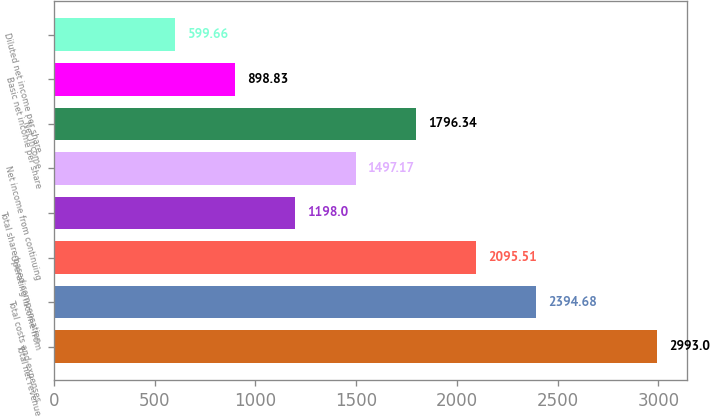Convert chart to OTSL. <chart><loc_0><loc_0><loc_500><loc_500><bar_chart><fcel>Total net revenue<fcel>Total costs and expenses<fcel>Operating income from<fcel>Total share-based compensation<fcel>Net income from continuing<fcel>Net income<fcel>Basic net income per share<fcel>Diluted net income per share<nl><fcel>2993<fcel>2394.68<fcel>2095.51<fcel>1198<fcel>1497.17<fcel>1796.34<fcel>898.83<fcel>599.66<nl></chart> 